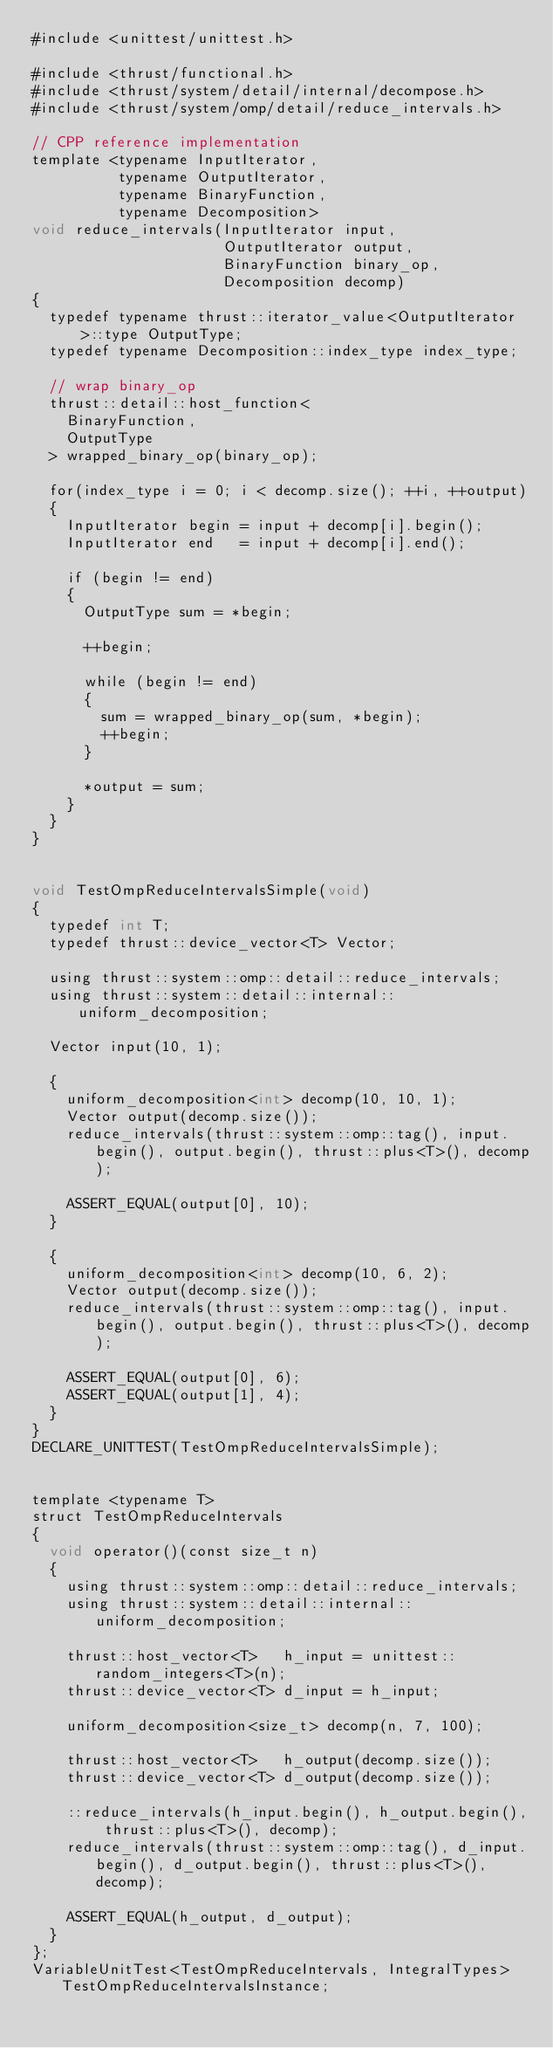Convert code to text. <code><loc_0><loc_0><loc_500><loc_500><_Cuda_>#include <unittest/unittest.h>

#include <thrust/functional.h>
#include <thrust/system/detail/internal/decompose.h>
#include <thrust/system/omp/detail/reduce_intervals.h>

// CPP reference implementation 
template <typename InputIterator,
          typename OutputIterator,
          typename BinaryFunction,
          typename Decomposition>
void reduce_intervals(InputIterator input,
                      OutputIterator output,
                      BinaryFunction binary_op,
                      Decomposition decomp)
{
  typedef typename thrust::iterator_value<OutputIterator>::type OutputType;
  typedef typename Decomposition::index_type index_type;

  // wrap binary_op
  thrust::detail::host_function<
    BinaryFunction,
    OutputType
  > wrapped_binary_op(binary_op);

  for(index_type i = 0; i < decomp.size(); ++i, ++output)
  {
    InputIterator begin = input + decomp[i].begin();
    InputIterator end   = input + decomp[i].end();

    if (begin != end)
    {
      OutputType sum = *begin;

      ++begin;

      while (begin != end)
      {
        sum = wrapped_binary_op(sum, *begin);
        ++begin;
      }

      *output = sum;
    }
  }
}


void TestOmpReduceIntervalsSimple(void)
{
  typedef int T;
  typedef thrust::device_vector<T> Vector;

  using thrust::system::omp::detail::reduce_intervals;
  using thrust::system::detail::internal::uniform_decomposition;

  Vector input(10, 1);
    
  {
    uniform_decomposition<int> decomp(10, 10, 1);
    Vector output(decomp.size());
    reduce_intervals(thrust::system::omp::tag(), input.begin(), output.begin(), thrust::plus<T>(), decomp);

    ASSERT_EQUAL(output[0], 10);
  }
  
  {
    uniform_decomposition<int> decomp(10, 6, 2);
    Vector output(decomp.size());
    reduce_intervals(thrust::system::omp::tag(), input.begin(), output.begin(), thrust::plus<T>(), decomp);

    ASSERT_EQUAL(output[0], 6);
    ASSERT_EQUAL(output[1], 4);
  }
}
DECLARE_UNITTEST(TestOmpReduceIntervalsSimple);


template <typename T>
struct TestOmpReduceIntervals
{
  void operator()(const size_t n)
  {
    using thrust::system::omp::detail::reduce_intervals;
    using thrust::system::detail::internal::uniform_decomposition;
    
    thrust::host_vector<T>   h_input = unittest::random_integers<T>(n);
    thrust::device_vector<T> d_input = h_input;

    uniform_decomposition<size_t> decomp(n, 7, 100);

    thrust::host_vector<T>   h_output(decomp.size());
    thrust::device_vector<T> d_output(decomp.size());
    
    ::reduce_intervals(h_input.begin(), h_output.begin(), thrust::plus<T>(), decomp);
    reduce_intervals(thrust::system::omp::tag(), d_input.begin(), d_output.begin(), thrust::plus<T>(), decomp);

    ASSERT_EQUAL(h_output, d_output);
  }
};
VariableUnitTest<TestOmpReduceIntervals, IntegralTypes> TestOmpReduceIntervalsInstance;

</code> 